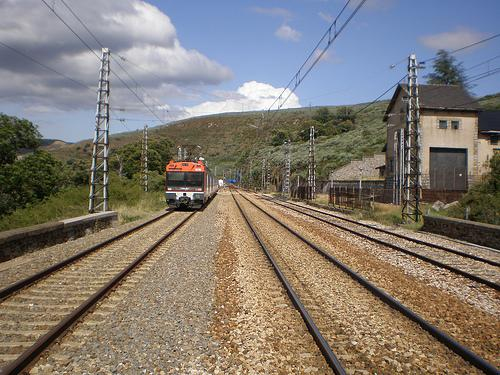What does the sky look like in this image? The sky is cloudy with white puffy clouds on the horizon and a blue backdrop. How would you describe the texture of the clouds in this image? The clouds are fluffy and white, with greyish tints scattered across the sky, giving a sense of depth and volume. Explain the surroundings of the train tracks in the picture. The train tracks are surrounded by grassy hills, green trees, an old building, metal electrical towers, and a stone wall. What is the sentiment or mood evoked by this image? The image evokes a somewhat nostalgic and peaceful mood, as it captures a train journeying through a serene countryside marked by green hills and trees. What color is the train in the image, and what is it doing? The train is orange and white, and it's moving forward on the train tracks. Count the number of windows visible on the train engine. There are two front windows visible on the train engine. Describe the building that is close to the train tracks. The building is beige with small windows, a large door, and a brown roof. It also has a side door and a tall grey street light nearby. What type of electric equipment can be seen near the train tracks? There are electrical wires over the train tracks, metal electric towers, and black power lines visible near the train tracks. How is the ground and the immediate environment around the train tracks depicted? The ground is brown with stone gravel and a mix of grass and rocks near a small rock wall and a curb beside the rail road tracks. 